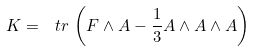Convert formula to latex. <formula><loc_0><loc_0><loc_500><loc_500>K = \ t r \, \left ( F \wedge A - \frac { 1 } { 3 } A \wedge A \wedge A \right )</formula> 